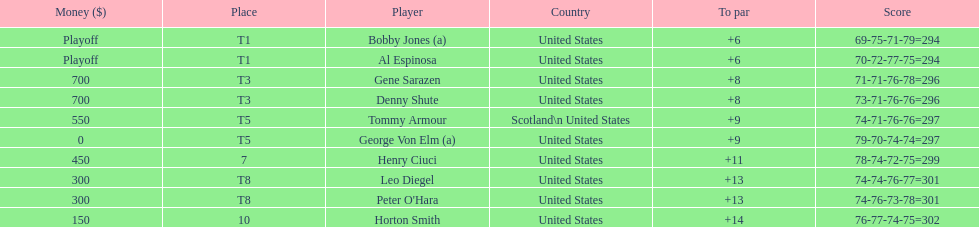Who was the last player in the top 10? Horton Smith. 